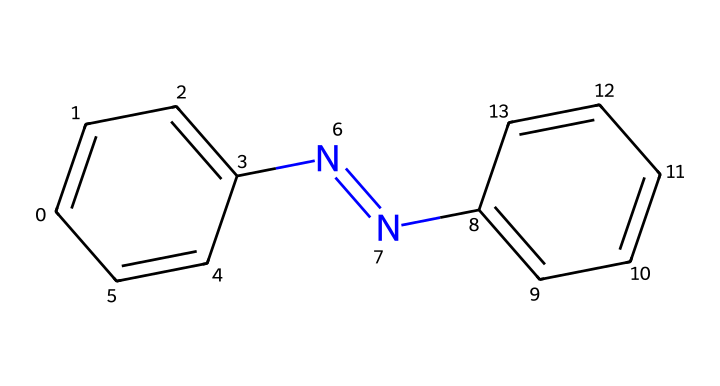What is the molecular formula of azobenzene? The molecular formula can be obtained by counting the atoms present in the structure. The chemical contains 12 carbon atoms (C), 10 hydrogen atoms (H), and 2 nitrogen atoms (N) based on the structure.
Answer: C12H10N2 How many nitrogen atoms are present in azobenzene? Counting the atoms in the structure, there are 2 nitrogen atoms present.
Answer: 2 What type of chemical bond connects the two nitrogen atoms in azobenzene? The two nitrogen atoms are connected by a double bond, which is indicated by the "=" symbol in structural representations of nitrogen double bonds.
Answer: double bond Which part of the azobenzene structure is responsible for its photoreactivity? The azo group (N=N) in the structure is responsible for photoreactivity, as the double bond can undergo trans-cis isomerization upon exposure to light.
Answer: azo group What is the significance of the phenyl groups in azobenzene? The phenyl groups provide stability to the overall molecule and influence its optical properties due to their ability to absorb light.
Answer: stability and optical properties What is the total number of aromatic rings in azobenzene? Azobenzene contains 2 aromatic rings, one on each side of the azo group. This can be determined by identifying the phenyl groups attached to the nitrogen atoms.
Answer: 2 How does the symmetry of azobenzene affect its properties? The symmetry of azobenzene contributes to its uniform behavior in light absorption and photochemical reactions, which can be derived from analyzing the symmetrical arrangement of the phenyl groups relative to the azo bond.
Answer: uniform behavior 